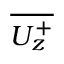<formula> <loc_0><loc_0><loc_500><loc_500>\overline { { U _ { z } ^ { + } } }</formula> 